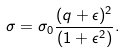Convert formula to latex. <formula><loc_0><loc_0><loc_500><loc_500>\sigma = \sigma _ { 0 } \frac { ( q + \epsilon ) ^ { 2 } } { ( 1 + \epsilon ^ { 2 } ) } .</formula> 